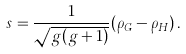<formula> <loc_0><loc_0><loc_500><loc_500>s = \frac { 1 } { \sqrt { g ( g + 1 ) } } ( \rho _ { G } - \rho _ { H } ) \, .</formula> 